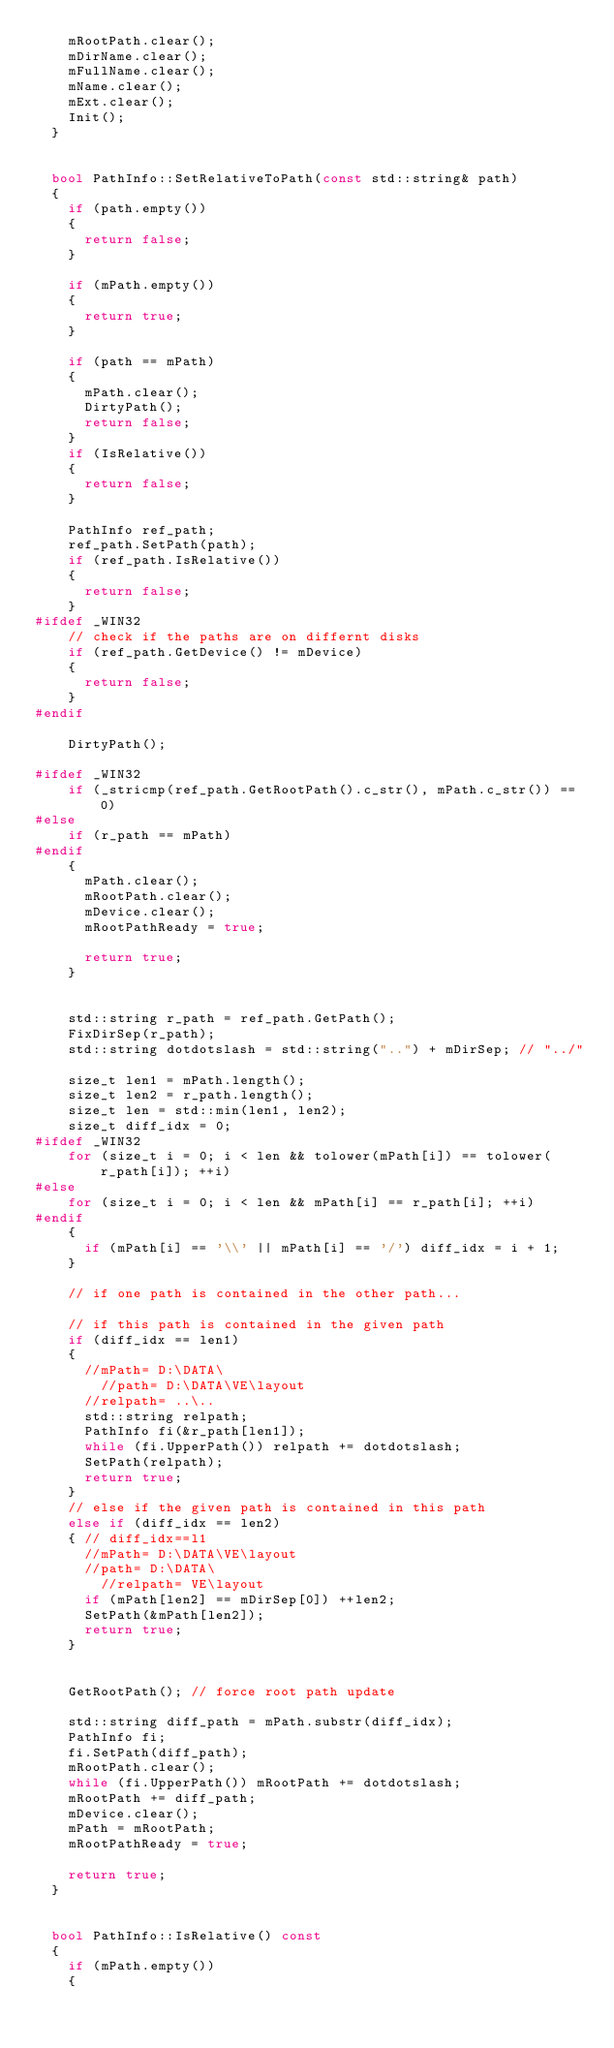Convert code to text. <code><loc_0><loc_0><loc_500><loc_500><_C++_>		mRootPath.clear();
		mDirName.clear();
		mFullName.clear();
		mName.clear();
		mExt.clear();
		Init();
	}


	bool PathInfo::SetRelativeToPath(const std::string& path)
	{
		if (path.empty())
		{
			return false;
		}

		if (mPath.empty())
		{
			return true;
		}

		if (path == mPath)
		{
			mPath.clear();
			DirtyPath();
			return false;
		}
		if (IsRelative())
		{
			return false;
		}

		PathInfo ref_path;
		ref_path.SetPath(path);
		if (ref_path.IsRelative())
		{
			return false;
		}
#ifdef _WIN32
		// check if the paths are on differnt disks
		if (ref_path.GetDevice() != mDevice)
		{
			return false;
		}
#endif

		DirtyPath();

#ifdef _WIN32
		if (_stricmp(ref_path.GetRootPath().c_str(), mPath.c_str()) == 0)
#else
		if (r_path == mPath)
#endif
		{
			mPath.clear();
			mRootPath.clear();
			mDevice.clear();
			mRootPathReady = true;

			return true;
		}


		std::string r_path = ref_path.GetPath();
		FixDirSep(r_path);
		std::string dotdotslash = std::string("..") + mDirSep; // "../"

		size_t len1 = mPath.length();
		size_t len2 = r_path.length();
		size_t len = std::min(len1, len2);
		size_t diff_idx = 0;
#ifdef _WIN32
		for (size_t i = 0; i < len && tolower(mPath[i]) == tolower(r_path[i]); ++i)
#else
		for (size_t i = 0; i < len && mPath[i] == r_path[i]; ++i)
#endif
		{
			if (mPath[i] == '\\' || mPath[i] == '/') diff_idx = i + 1;
		}

		// if one path is contained in the other path...

		// if this path is contained in the given path
		if (diff_idx == len1)
		{
			//mPath= D:\DATA\
		    //path= D:\DATA\VE\layout
			//relpath= ..\..
			std::string relpath;
			PathInfo fi(&r_path[len1]);
			while (fi.UpperPath()) relpath += dotdotslash;
			SetPath(relpath);
			return true;
		}
		// else if the given path is contained in this path
		else if (diff_idx == len2)
		{ // diff_idx==l1
		  //mPath= D:\DATA\VE\layout
		  //path= D:\DATA\
	      //relpath= VE\layout
			if (mPath[len2] == mDirSep[0]) ++len2;
			SetPath(&mPath[len2]);
			return true;
		}


		GetRootPath(); // force root path update

		std::string diff_path = mPath.substr(diff_idx);
		PathInfo fi;
		fi.SetPath(diff_path);
		mRootPath.clear();
		while (fi.UpperPath()) mRootPath += dotdotslash;
		mRootPath += diff_path;
		mDevice.clear();
		mPath = mRootPath;
		mRootPathReady = true;

		return true;
	}


	bool PathInfo::IsRelative() const
	{
		if (mPath.empty())
		{</code> 